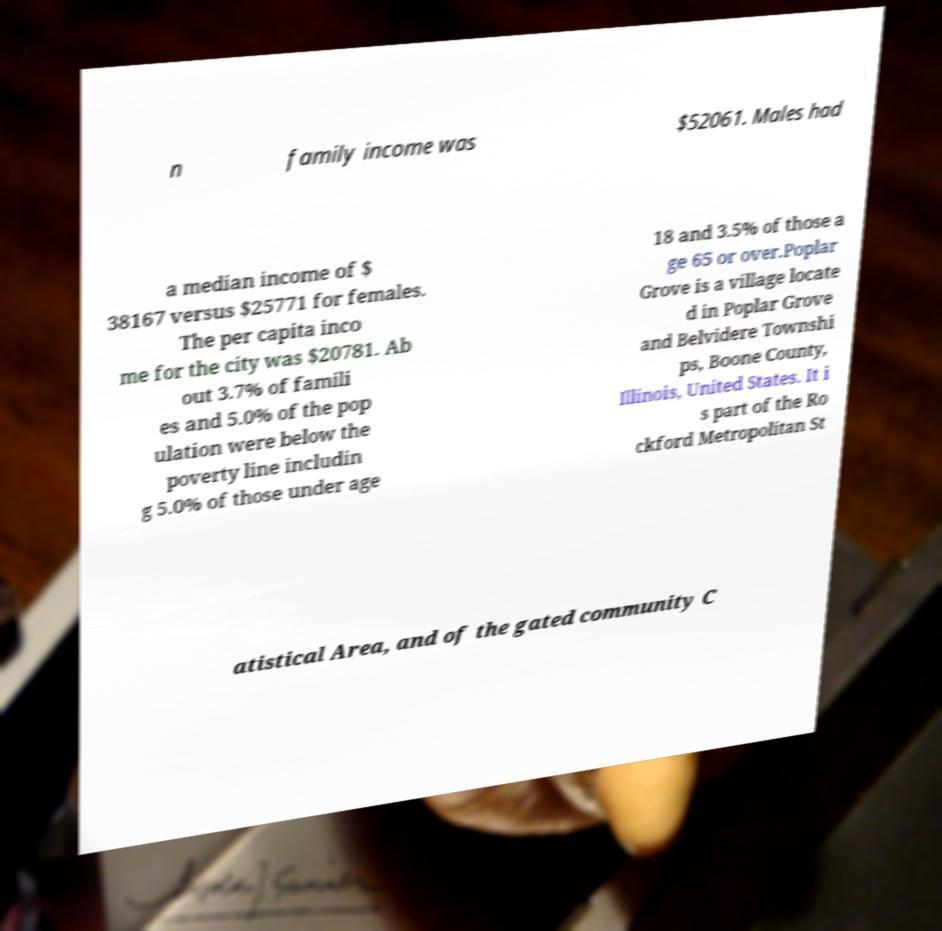There's text embedded in this image that I need extracted. Can you transcribe it verbatim? n family income was $52061. Males had a median income of $ 38167 versus $25771 for females. The per capita inco me for the city was $20781. Ab out 3.7% of famili es and 5.0% of the pop ulation were below the poverty line includin g 5.0% of those under age 18 and 3.5% of those a ge 65 or over.Poplar Grove is a village locate d in Poplar Grove and Belvidere Townshi ps, Boone County, Illinois, United States. It i s part of the Ro ckford Metropolitan St atistical Area, and of the gated community C 